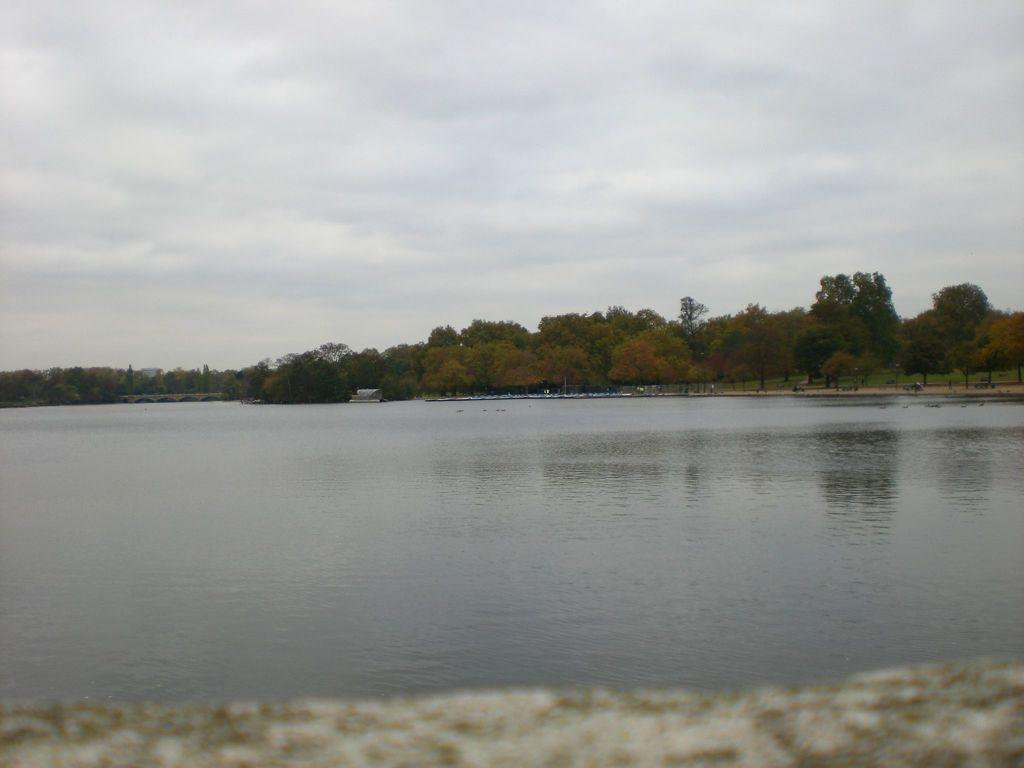What is visible in the image? Water is visible in the image. What can be seen in the background of the image? There are trees and clouds visible in the background of the image. What is the purpose of the vase in the image? There is no vase present in the image, so it is not possible to determine its purpose. 